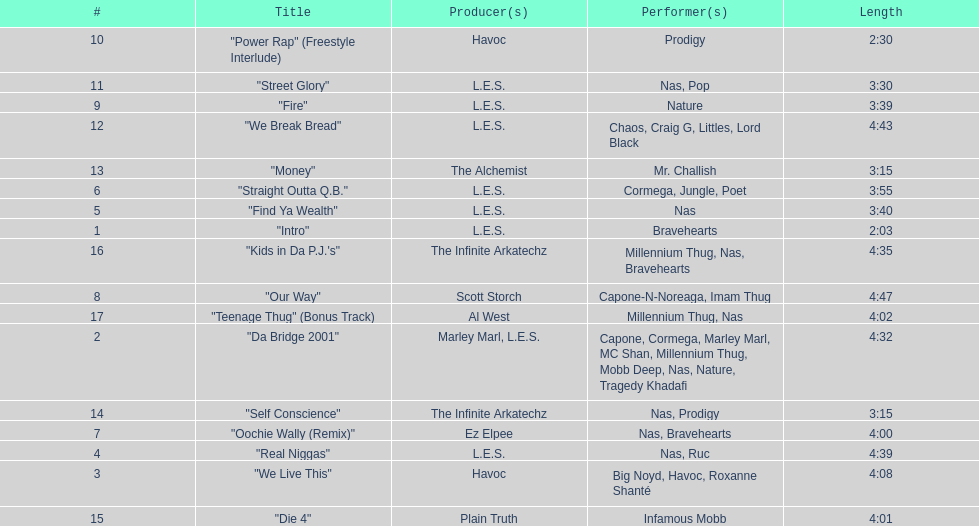How many songs were on the track list? 17. 